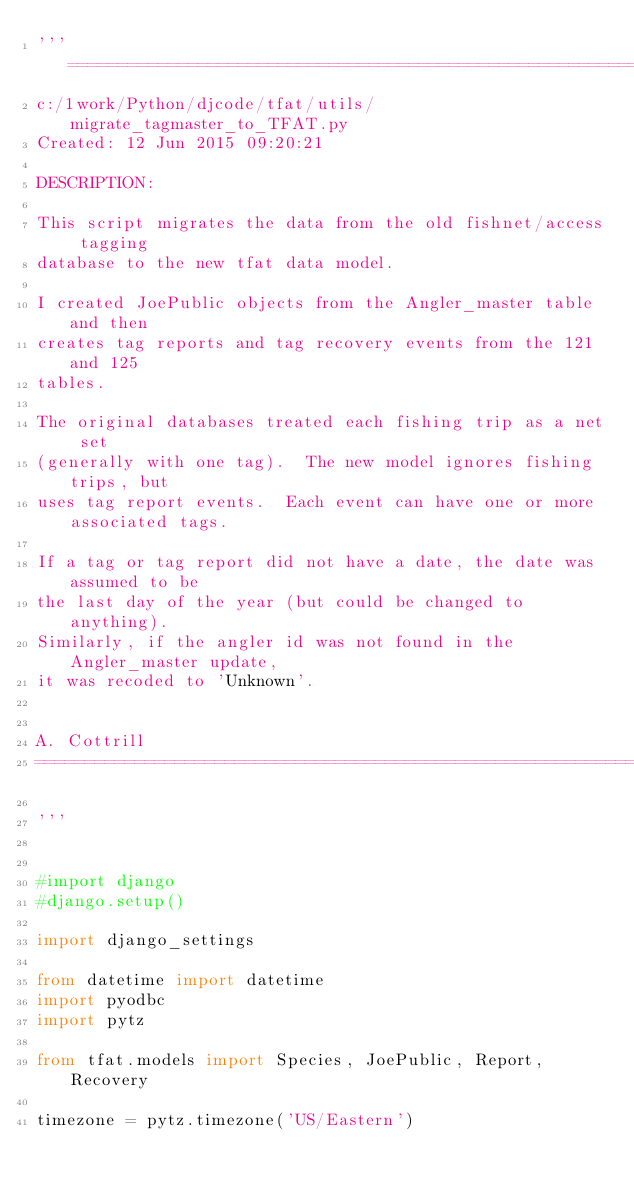<code> <loc_0><loc_0><loc_500><loc_500><_Python_>'''=============================================================
c:/1work/Python/djcode/tfat/utils/migrate_tagmaster_to_TFAT.py
Created: 12 Jun 2015 09:20:21

DESCRIPTION:

This script migrates the data from the old fishnet/access tagging
database to the new tfat data model.

I created JoePublic objects from the Angler_master table and then
creates tag reports and tag recovery events from the 121 and 125
tables.

The original databases treated each fishing trip as a net set
(generally with one tag).  The new model ignores fishing trips, but
uses tag report events.  Each event can have one or more associated tags.

If a tag or tag report did not have a date, the date was assumed to be
the last day of the year (but could be changed to anything).
Similarly, if the angler id was not found in the Angler_master update,
it was recoded to 'Unknown'.


A. Cottrill
=============================================================

'''


#import django
#django.setup()

import django_settings

from datetime import datetime
import pyodbc
import pytz

from tfat.models import Species, JoePublic, Report, Recovery

timezone = pytz.timezone('US/Eastern')
</code> 